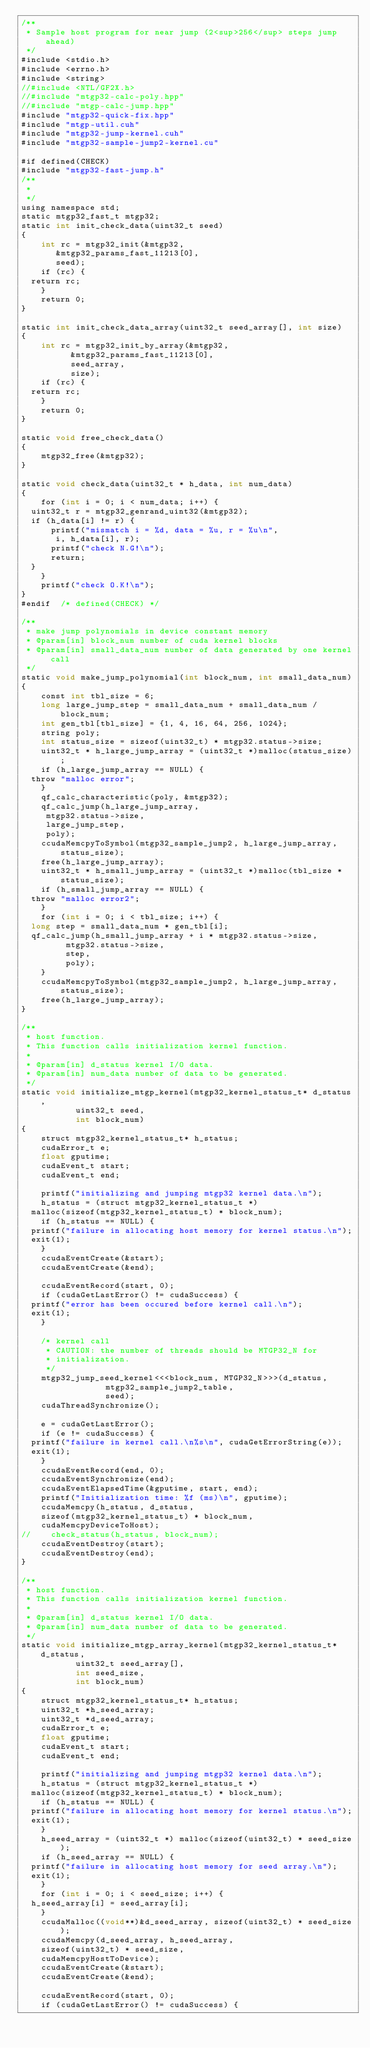Convert code to text. <code><loc_0><loc_0><loc_500><loc_500><_Cuda_>/**
 * Sample host program for near jump (2<sup>256</sup> steps jump ahead)
 */
#include <stdio.h>
#include <errno.h>
#include <string>
//#include <NTL/GF2X.h>
//#include "mtgp32-calc-poly.hpp"
//#include "mtgp-calc-jump.hpp"
#include "mtgp32-quick-fix.hpp"
#include "mtgp-util.cuh"
#include "mtgp32-jump-kernel.cuh"
#include "mtgp32-sample-jump2-kernel.cu"

#if defined(CHECK)
#include "mtgp32-fast-jump.h"
/**
 *
 */
using namespace std;
static mtgp32_fast_t mtgp32;
static int init_check_data(uint32_t seed)
{
    int rc = mtgp32_init(&mtgp32,
			 &mtgp32_params_fast_11213[0],
			 seed);
    if (rc) {
	return rc;
    }
    return 0;
}

static int init_check_data_array(uint32_t seed_array[], int size)
{
    int rc = mtgp32_init_by_array(&mtgp32,
				  &mtgp32_params_fast_11213[0],
				  seed_array,
				  size);
    if (rc) {
	return rc;
    }
    return 0;
}

static void free_check_data()
{
    mtgp32_free(&mtgp32);
}

static void check_data(uint32_t * h_data, int num_data)
{
    for (int i = 0; i < num_data; i++) {
	uint32_t r = mtgp32_genrand_uint32(&mtgp32);
	if (h_data[i] != r) {
	    printf("mismatch i = %d, data = %u, r = %u\n",
		   i, h_data[i], r);
	    printf("check N.G!\n");
	    return;
	}
    }
    printf("check O.K!\n");
}
#endif	/* defined(CHECK) */

/**
 * make jump polynomials in device constant memory
 * @param[in] block_num number of cuda kernel blocks
 * @param[in] small_data_num number of data generated by one kernel call
 */
static void make_jump_polynomial(int block_num, int small_data_num)
{
    const int tbl_size = 6;
    long large_jump_step = small_data_num + small_data_num / block_num;
    int gen_tbl[tbl_size] = {1, 4, 16, 64, 256, 1024};
    string poly;
    int status_size = sizeof(uint32_t) * mtgp32.status->size;
    uint32_t * h_large_jump_array = (uint32_t *)malloc(status_size);
    if (h_large_jump_array == NULL) {
	throw "malloc error";
    }
    qf_calc_characteristic(poly, &mtgp32);
    qf_calc_jump(h_large_jump_array,
		 mtgp32.status->size,
		 large_jump_step,
		 poly);
    ccudaMemcpyToSymbol(mtgp32_sample_jump2, h_large_jump_array, status_size);
    free(h_large_jump_array);
    uint32_t * h_small_jump_array = (uint32_t *)malloc(tbl_size * status_size);
    if (h_small_jump_array == NULL) {
	throw "malloc error2";
    }
    for (int i = 0; i < tbl_size; i++) {
	long step = small_data_num * gen_tbl[i];
	qf_calc_jump(h_small_jump_array + i * mtgp32.status->size,
		     mtgp32.status->size,
		     step,
		     poly);
    }
    ccudaMemcpyToSymbol(mtgp32_sample_jump2, h_large_jump_array, status_size);
    free(h_large_jump_array);
}

/**
 * host function.
 * This function calls initialization kernel function.
 *
 * @param[in] d_status kernel I/O data.
 * @param[in] num_data number of data to be generated.
 */
static void initialize_mtgp_kernel(mtgp32_kernel_status_t* d_status,
				   uint32_t seed,
				   int block_num)
{
    struct mtgp32_kernel_status_t* h_status;
    cudaError_t e;
    float gputime;
    cudaEvent_t start;
    cudaEvent_t end;

    printf("initializing and jumping mtgp32 kernel data.\n");
    h_status = (struct mtgp32_kernel_status_t *)
	malloc(sizeof(mtgp32_kernel_status_t) * block_num);
    if (h_status == NULL) {
	printf("failure in allocating host memory for kernel status.\n");
	exit(1);
    }
    ccudaEventCreate(&start);
    ccudaEventCreate(&end);

    ccudaEventRecord(start, 0);
    if (cudaGetLastError() != cudaSuccess) {
	printf("error has been occured before kernel call.\n");
	exit(1);
    }

    /* kernel call
     * CAUTION: the number of threads should be MTGP32_N for
     * initialization.
     */
    mtgp32_jump_seed_kernel<<<block_num, MTGP32_N>>>(d_status,
						     mtgp32_sample_jump2_table,
						     seed);
    cudaThreadSynchronize();

    e = cudaGetLastError();
    if (e != cudaSuccess) {
	printf("failure in kernel call.\n%s\n", cudaGetErrorString(e));
	exit(1);
    }
    ccudaEventRecord(end, 0);
    ccudaEventSynchronize(end);
    ccudaEventElapsedTime(&gputime, start, end);
    printf("Initialization time: %f (ms)\n", gputime);
    ccudaMemcpy(h_status, d_status,
		sizeof(mtgp32_kernel_status_t) * block_num,
		cudaMemcpyDeviceToHost);
//    check_status(h_status, block_num);
    ccudaEventDestroy(start);
    ccudaEventDestroy(end);
}

/**
 * host function.
 * This function calls initialization kernel function.
 *
 * @param[in] d_status kernel I/O data.
 * @param[in] num_data number of data to be generated.
 */
static void initialize_mtgp_array_kernel(mtgp32_kernel_status_t* d_status,
					 uint32_t seed_array[],
					 int seed_size,
					 int block_num)
{
    struct mtgp32_kernel_status_t* h_status;
    uint32_t *h_seed_array;
    uint32_t *d_seed_array;
    cudaError_t e;
    float gputime;
    cudaEvent_t start;
    cudaEvent_t end;

    printf("initializing and jumping mtgp32 kernel data.\n");
    h_status = (struct mtgp32_kernel_status_t *)
	malloc(sizeof(mtgp32_kernel_status_t) * block_num);
    if (h_status == NULL) {
	printf("failure in allocating host memory for kernel status.\n");
	exit(1);
    }
    h_seed_array = (uint32_t *) malloc(sizeof(uint32_t) * seed_size);
    if (h_seed_array == NULL) {
	printf("failure in allocating host memory for seed array.\n");
	exit(1);
    }
    for (int i = 0; i < seed_size; i++) {
	h_seed_array[i] = seed_array[i];
    }
    ccudaMalloc((void**)&d_seed_array, sizeof(uint32_t) * seed_size);
    ccudaMemcpy(d_seed_array, h_seed_array,
		sizeof(uint32_t) * seed_size,
		cudaMemcpyHostToDevice);
    ccudaEventCreate(&start);
    ccudaEventCreate(&end);

    ccudaEventRecord(start, 0);
    if (cudaGetLastError() != cudaSuccess) {</code> 